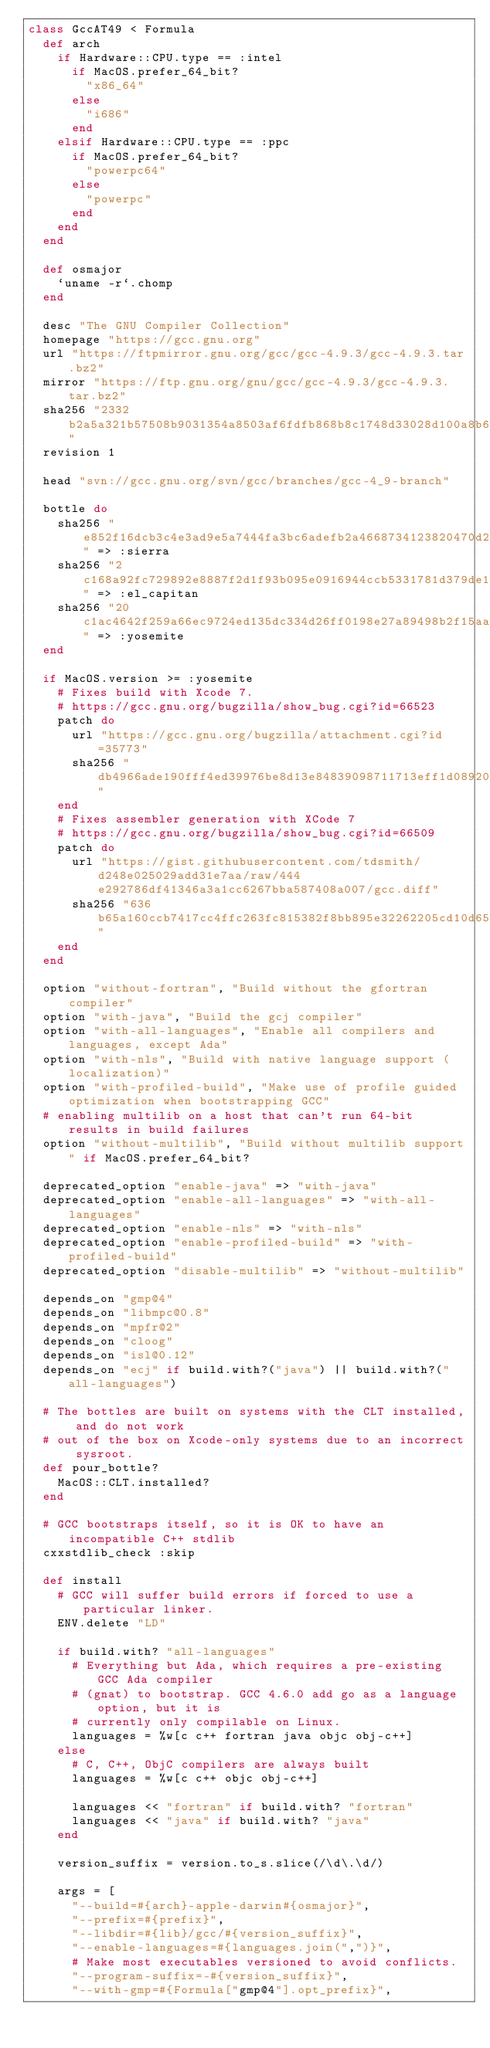Convert code to text. <code><loc_0><loc_0><loc_500><loc_500><_Ruby_>class GccAT49 < Formula
  def arch
    if Hardware::CPU.type == :intel
      if MacOS.prefer_64_bit?
        "x86_64"
      else
        "i686"
      end
    elsif Hardware::CPU.type == :ppc
      if MacOS.prefer_64_bit?
        "powerpc64"
      else
        "powerpc"
      end
    end
  end

  def osmajor
    `uname -r`.chomp
  end

  desc "The GNU Compiler Collection"
  homepage "https://gcc.gnu.org"
  url "https://ftpmirror.gnu.org/gcc/gcc-4.9.3/gcc-4.9.3.tar.bz2"
  mirror "https://ftp.gnu.org/gnu/gcc/gcc-4.9.3/gcc-4.9.3.tar.bz2"
  sha256 "2332b2a5a321b57508b9031354a8503af6fdfb868b8c1748d33028d100a8b67e"
  revision 1

  head "svn://gcc.gnu.org/svn/gcc/branches/gcc-4_9-branch"

  bottle do
    sha256 "e852f16dcb3c4e3ad9e5a7444fa3bc6adefb2a4668734123820470d2ae425d89" => :sierra
    sha256 "2c168a92fc729892e8887f2d1f93b095e0916944ccb5331781d379de1137ce05" => :el_capitan
    sha256 "20c1ac4642f259a66ec9724ed135dc334d26ff0198e27a89498b2f15aa1f77c5" => :yosemite
  end

  if MacOS.version >= :yosemite
    # Fixes build with Xcode 7.
    # https://gcc.gnu.org/bugzilla/show_bug.cgi?id=66523
    patch do
      url "https://gcc.gnu.org/bugzilla/attachment.cgi?id=35773"
      sha256 "db4966ade190fff4ed39976be8d13e84839098711713eff1d08920d37a58f5ec"
    end
    # Fixes assembler generation with XCode 7
    # https://gcc.gnu.org/bugzilla/show_bug.cgi?id=66509
    patch do
      url "https://gist.githubusercontent.com/tdsmith/d248e025029add31e7aa/raw/444e292786df41346a3a1cc6267bba587408a007/gcc.diff"
      sha256 "636b65a160ccb7417cc4ffc263fc815382f8bb895e32262205cd10d65ea7804a"
    end
  end

  option "without-fortran", "Build without the gfortran compiler"
  option "with-java", "Build the gcj compiler"
  option "with-all-languages", "Enable all compilers and languages, except Ada"
  option "with-nls", "Build with native language support (localization)"
  option "with-profiled-build", "Make use of profile guided optimization when bootstrapping GCC"
  # enabling multilib on a host that can't run 64-bit results in build failures
  option "without-multilib", "Build without multilib support" if MacOS.prefer_64_bit?

  deprecated_option "enable-java" => "with-java"
  deprecated_option "enable-all-languages" => "with-all-languages"
  deprecated_option "enable-nls" => "with-nls"
  deprecated_option "enable-profiled-build" => "with-profiled-build"
  deprecated_option "disable-multilib" => "without-multilib"

  depends_on "gmp@4"
  depends_on "libmpc@0.8"
  depends_on "mpfr@2"
  depends_on "cloog"
  depends_on "isl@0.12"
  depends_on "ecj" if build.with?("java") || build.with?("all-languages")

  # The bottles are built on systems with the CLT installed, and do not work
  # out of the box on Xcode-only systems due to an incorrect sysroot.
  def pour_bottle?
    MacOS::CLT.installed?
  end

  # GCC bootstraps itself, so it is OK to have an incompatible C++ stdlib
  cxxstdlib_check :skip

  def install
    # GCC will suffer build errors if forced to use a particular linker.
    ENV.delete "LD"

    if build.with? "all-languages"
      # Everything but Ada, which requires a pre-existing GCC Ada compiler
      # (gnat) to bootstrap. GCC 4.6.0 add go as a language option, but it is
      # currently only compilable on Linux.
      languages = %w[c c++ fortran java objc obj-c++]
    else
      # C, C++, ObjC compilers are always built
      languages = %w[c c++ objc obj-c++]

      languages << "fortran" if build.with? "fortran"
      languages << "java" if build.with? "java"
    end

    version_suffix = version.to_s.slice(/\d\.\d/)

    args = [
      "--build=#{arch}-apple-darwin#{osmajor}",
      "--prefix=#{prefix}",
      "--libdir=#{lib}/gcc/#{version_suffix}",
      "--enable-languages=#{languages.join(",")}",
      # Make most executables versioned to avoid conflicts.
      "--program-suffix=-#{version_suffix}",
      "--with-gmp=#{Formula["gmp@4"].opt_prefix}",</code> 